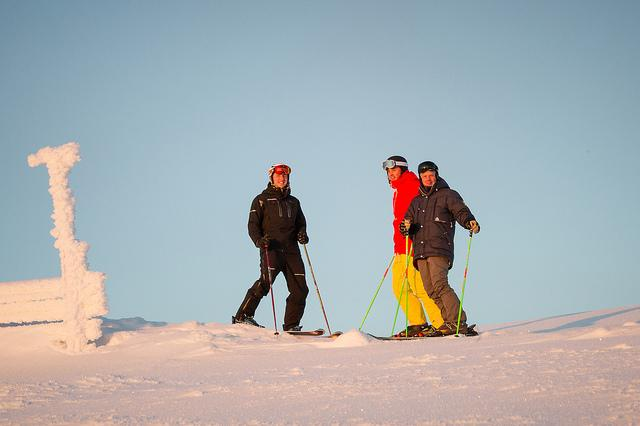Where will these men go next? downhill 